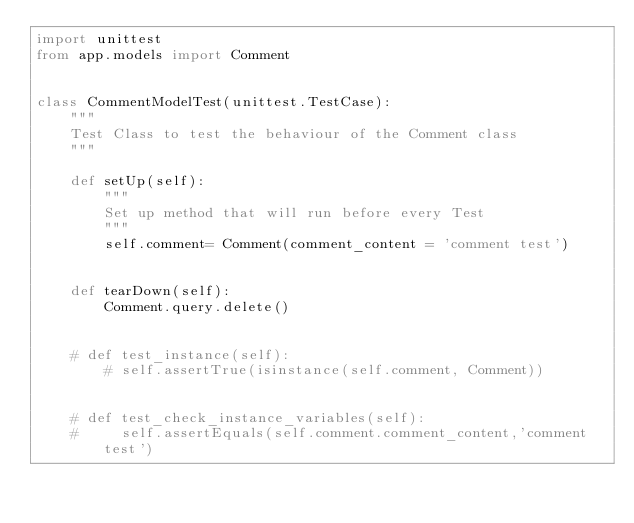Convert code to text. <code><loc_0><loc_0><loc_500><loc_500><_Python_>import unittest
from app.models import Comment


class CommentModelTest(unittest.TestCase):
    """
    Test Class to test the behaviour of the Comment class
    """

    def setUp(self):
        """
        Set up method that will run before every Test
        """
        self.comment= Comment(comment_content = 'comment test')


    def tearDown(self):
        Comment.query.delete()


    # def test_instance(self):
        # self.assertTrue(isinstance(self.comment, Comment))


    # def test_check_instance_variables(self):
    #     self.assertEquals(self.comment.comment_content,'comment test')</code> 